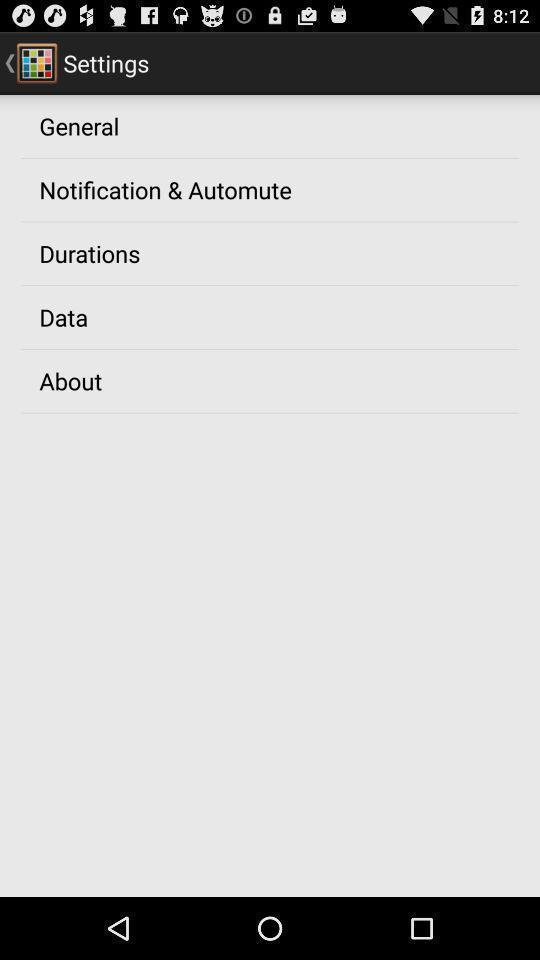Give me a summary of this screen capture. Screen showing settings page. 